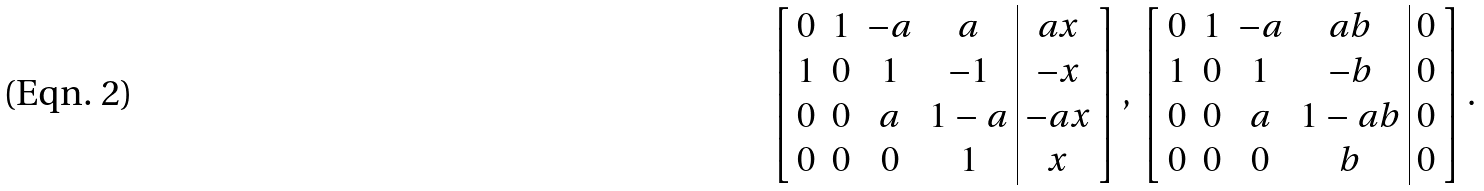Convert formula to latex. <formula><loc_0><loc_0><loc_500><loc_500>\left [ \begin{array} { c c c c | c } 0 & 1 & - a & a & a x \\ 1 & 0 & 1 & - 1 & - x \\ 0 & 0 & a & 1 - a & - a x \\ 0 & 0 & 0 & 1 & x \end{array} \right ] , \, \left [ \begin{array} { c c c c | c } 0 & 1 & - a & a b & 0 \\ 1 & 0 & 1 & - b & 0 \\ 0 & 0 & a & 1 - a b & 0 \\ 0 & 0 & 0 & b & 0 \end{array} \right ] .</formula> 